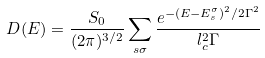<formula> <loc_0><loc_0><loc_500><loc_500>D ( E ) = \frac { S _ { 0 } } { ( 2 \pi ) ^ { 3 / 2 } } \sum _ { s \sigma } \frac { e ^ { - ( E - E _ { s } ^ { \sigma } ) ^ { 2 } / 2 \Gamma ^ { 2 } } } { l _ { c } ^ { 2 } \Gamma }</formula> 